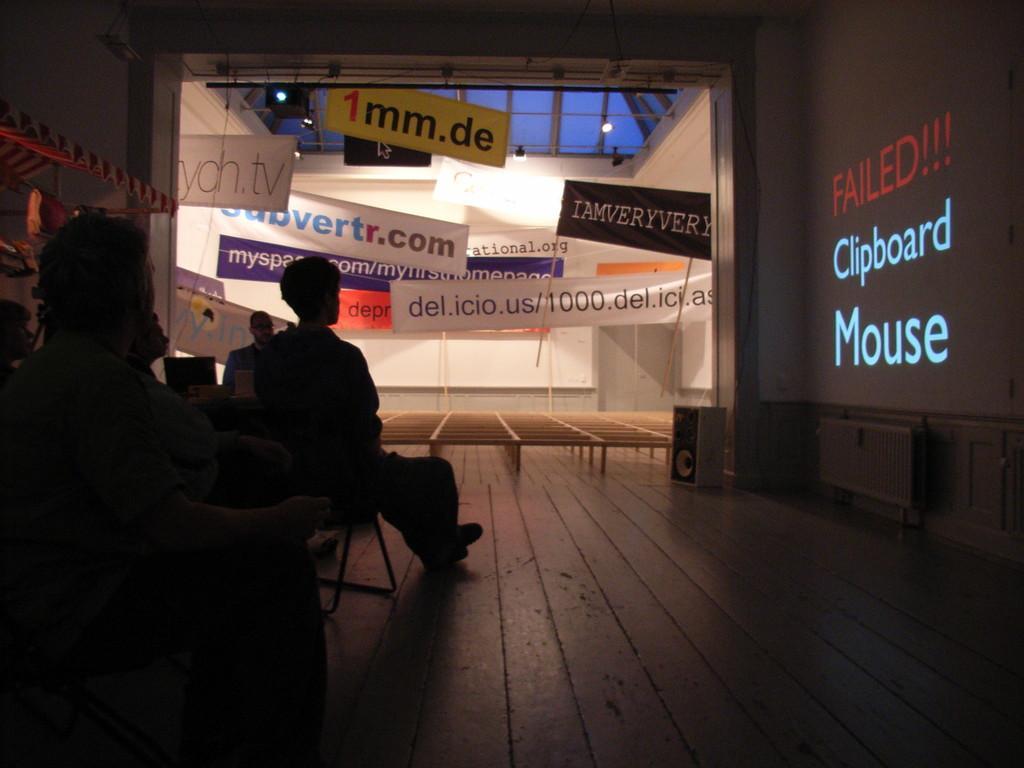Could you give a brief overview of what you see in this image? In the image we can see there are people sitting on the chair and there is a projector screen on the wall. There are banners pasted on the glass window. 